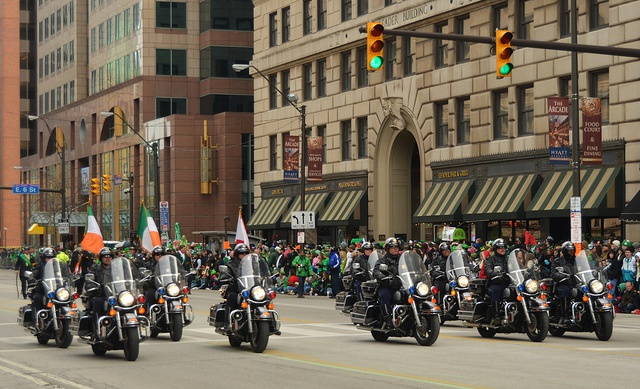Describe the objects in this image and their specific colors. I can see people in gray, black, and darkgray tones, motorcycle in gray, black, darkgray, and lightgray tones, motorcycle in gray, black, darkgray, and ivory tones, motorcycle in gray, black, darkgray, and lightgray tones, and motorcycle in gray, black, darkgray, and ivory tones in this image. 